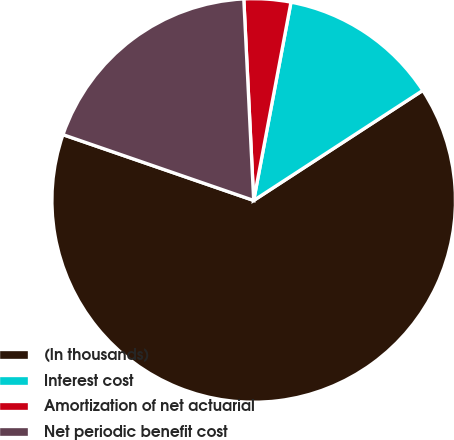Convert chart. <chart><loc_0><loc_0><loc_500><loc_500><pie_chart><fcel>(In thousands)<fcel>Interest cost<fcel>Amortization of net actuarial<fcel>Net periodic benefit cost<nl><fcel>64.47%<fcel>12.86%<fcel>3.74%<fcel>18.93%<nl></chart> 